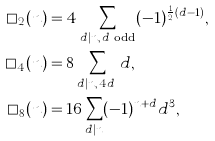Convert formula to latex. <formula><loc_0><loc_0><loc_500><loc_500>\square _ { 2 } ( n ) & = 4 \sum _ { d | n , \, d \text { odd} } ( - 1 ) ^ { \frac { 1 } { 2 } ( d - 1 ) } , \\ \square _ { 4 } ( n ) & = 8 \sum _ { d | n , \, 4 \nmid d } d , \\ \square _ { 8 } ( n ) & = 1 6 \sum _ { d | n } ( - 1 ) ^ { n + d } d ^ { 3 } ,</formula> 